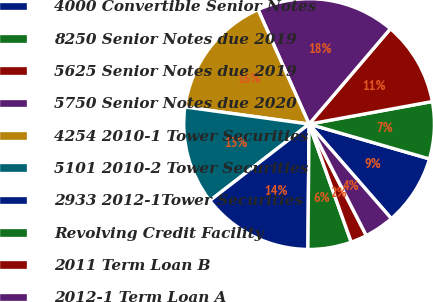<chart> <loc_0><loc_0><loc_500><loc_500><pie_chart><fcel>4000 Convertible Senior Notes<fcel>8250 Senior Notes due 2019<fcel>5625 Senior Notes due 2019<fcel>5750 Senior Notes due 2020<fcel>4254 2010-1 Tower Securities<fcel>5101 2010-2 Tower Securities<fcel>2933 2012-1Tower Securities<fcel>Revolving Credit Facility<fcel>2011 Term Loan B<fcel>2012-1 Term Loan A<nl><fcel>9.12%<fcel>7.36%<fcel>10.88%<fcel>17.91%<fcel>16.15%<fcel>12.64%<fcel>14.39%<fcel>5.61%<fcel>2.09%<fcel>3.85%<nl></chart> 